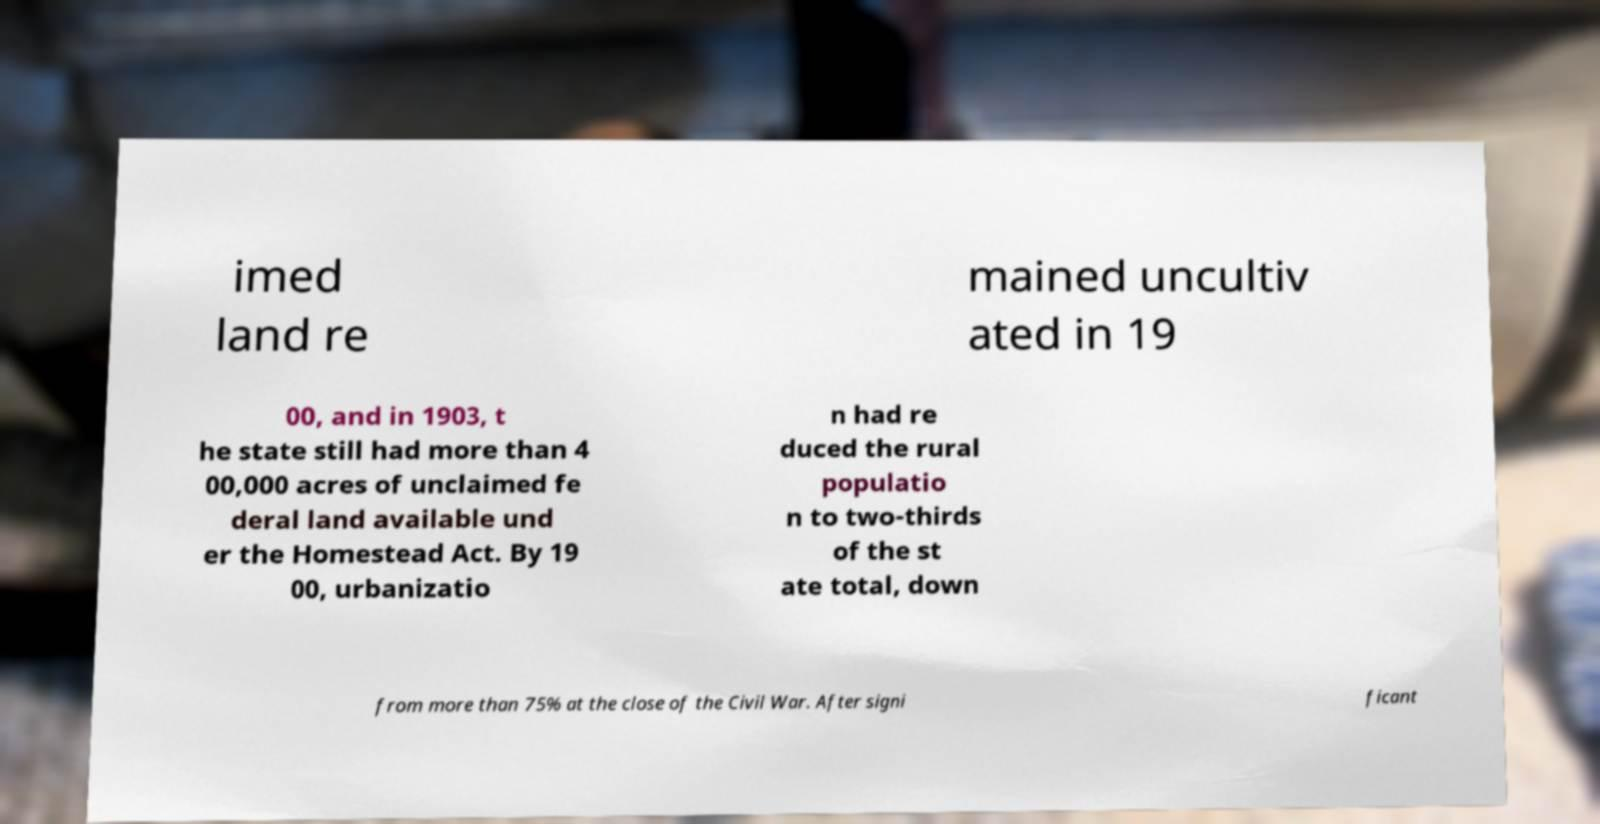Please identify and transcribe the text found in this image. imed land re mained uncultiv ated in 19 00, and in 1903, t he state still had more than 4 00,000 acres of unclaimed fe deral land available und er the Homestead Act. By 19 00, urbanizatio n had re duced the rural populatio n to two-thirds of the st ate total, down from more than 75% at the close of the Civil War. After signi ficant 